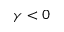<formula> <loc_0><loc_0><loc_500><loc_500>\gamma < 0</formula> 